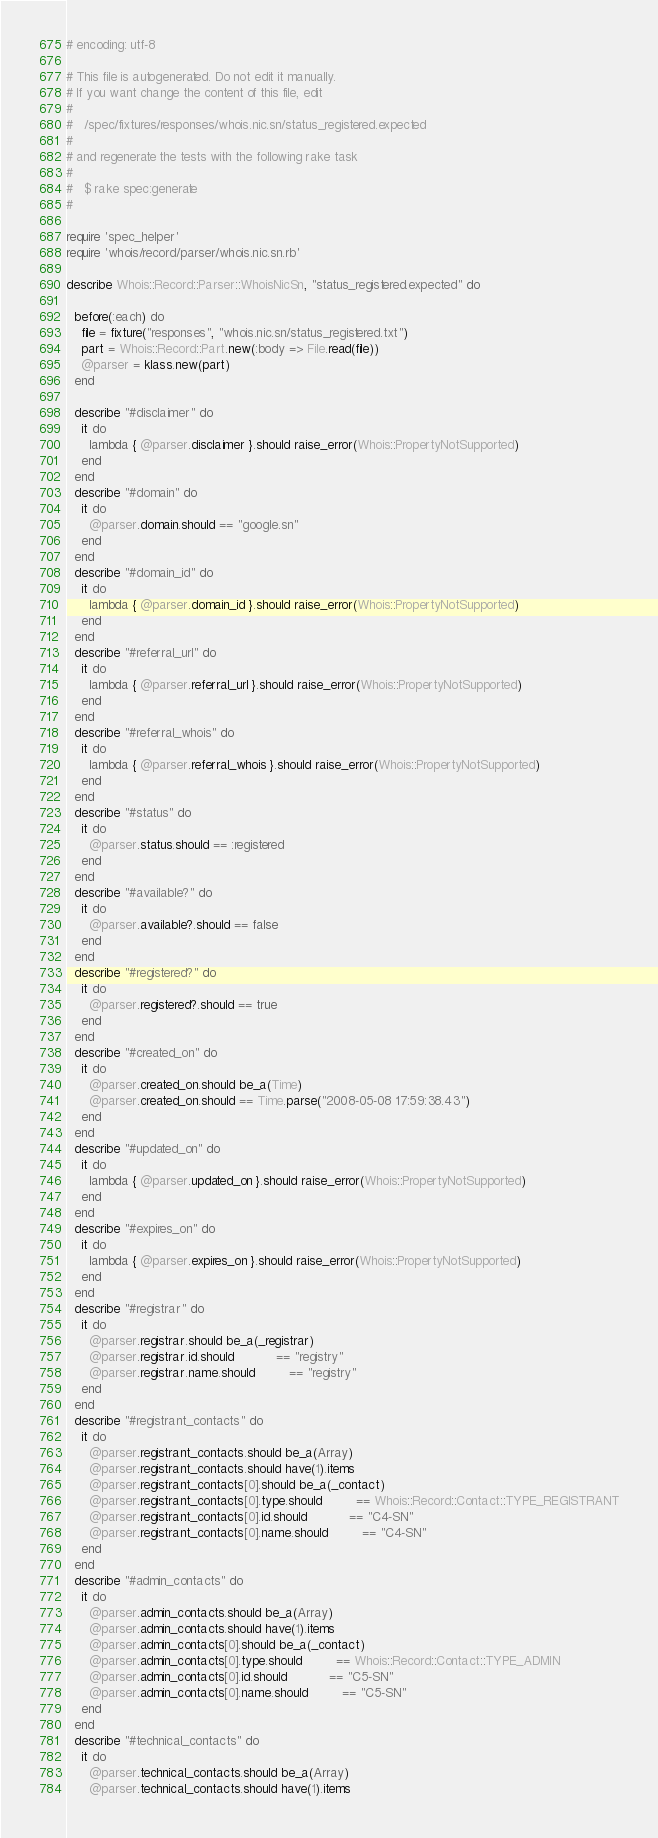<code> <loc_0><loc_0><loc_500><loc_500><_Ruby_># encoding: utf-8

# This file is autogenerated. Do not edit it manually.
# If you want change the content of this file, edit
#
#   /spec/fixtures/responses/whois.nic.sn/status_registered.expected
#
# and regenerate the tests with the following rake task
#
#   $ rake spec:generate
#

require 'spec_helper'
require 'whois/record/parser/whois.nic.sn.rb'

describe Whois::Record::Parser::WhoisNicSn, "status_registered.expected" do

  before(:each) do
    file = fixture("responses", "whois.nic.sn/status_registered.txt")
    part = Whois::Record::Part.new(:body => File.read(file))
    @parser = klass.new(part)
  end

  describe "#disclaimer" do
    it do
      lambda { @parser.disclaimer }.should raise_error(Whois::PropertyNotSupported)
    end
  end
  describe "#domain" do
    it do
      @parser.domain.should == "google.sn"
    end
  end
  describe "#domain_id" do
    it do
      lambda { @parser.domain_id }.should raise_error(Whois::PropertyNotSupported)
    end
  end
  describe "#referral_url" do
    it do
      lambda { @parser.referral_url }.should raise_error(Whois::PropertyNotSupported)
    end
  end
  describe "#referral_whois" do
    it do
      lambda { @parser.referral_whois }.should raise_error(Whois::PropertyNotSupported)
    end
  end
  describe "#status" do
    it do
      @parser.status.should == :registered
    end
  end
  describe "#available?" do
    it do
      @parser.available?.should == false
    end
  end
  describe "#registered?" do
    it do
      @parser.registered?.should == true
    end
  end
  describe "#created_on" do
    it do
      @parser.created_on.should be_a(Time)
      @parser.created_on.should == Time.parse("2008-05-08 17:59:38.43")
    end
  end
  describe "#updated_on" do
    it do
      lambda { @parser.updated_on }.should raise_error(Whois::PropertyNotSupported)
    end
  end
  describe "#expires_on" do
    it do
      lambda { @parser.expires_on }.should raise_error(Whois::PropertyNotSupported)
    end
  end
  describe "#registrar" do
    it do
      @parser.registrar.should be_a(_registrar)
      @parser.registrar.id.should           == "registry"
      @parser.registrar.name.should         == "registry"
    end
  end
  describe "#registrant_contacts" do
    it do
      @parser.registrant_contacts.should be_a(Array)
      @parser.registrant_contacts.should have(1).items
      @parser.registrant_contacts[0].should be_a(_contact)
      @parser.registrant_contacts[0].type.should         == Whois::Record::Contact::TYPE_REGISTRANT
      @parser.registrant_contacts[0].id.should           == "C4-SN"
      @parser.registrant_contacts[0].name.should         == "C4-SN"
    end
  end
  describe "#admin_contacts" do
    it do
      @parser.admin_contacts.should be_a(Array)
      @parser.admin_contacts.should have(1).items
      @parser.admin_contacts[0].should be_a(_contact)
      @parser.admin_contacts[0].type.should         == Whois::Record::Contact::TYPE_ADMIN
      @parser.admin_contacts[0].id.should           == "C5-SN"
      @parser.admin_contacts[0].name.should         == "C5-SN"
    end
  end
  describe "#technical_contacts" do
    it do
      @parser.technical_contacts.should be_a(Array)
      @parser.technical_contacts.should have(1).items</code> 